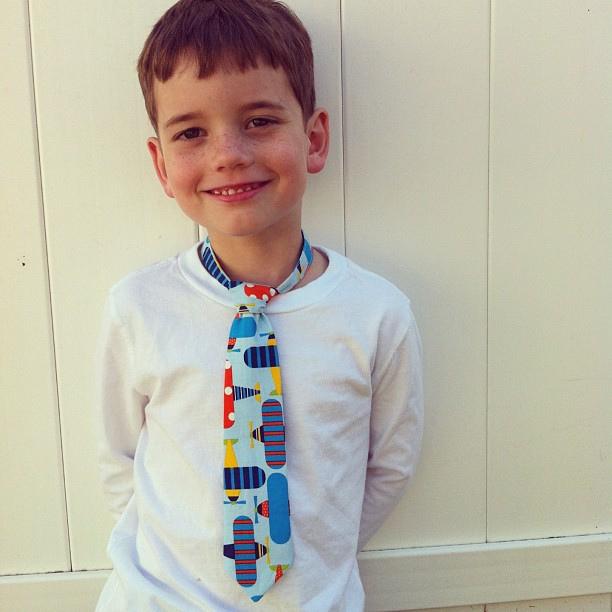Is the boy wearing a funny tie?
Give a very brief answer. Yes. Are his arms out?
Quick response, please. No. Do boys usually wear ties?
Answer briefly. No. How many colors are on the bib?
Short answer required. 7. Is he sad?
Write a very short answer. No. 